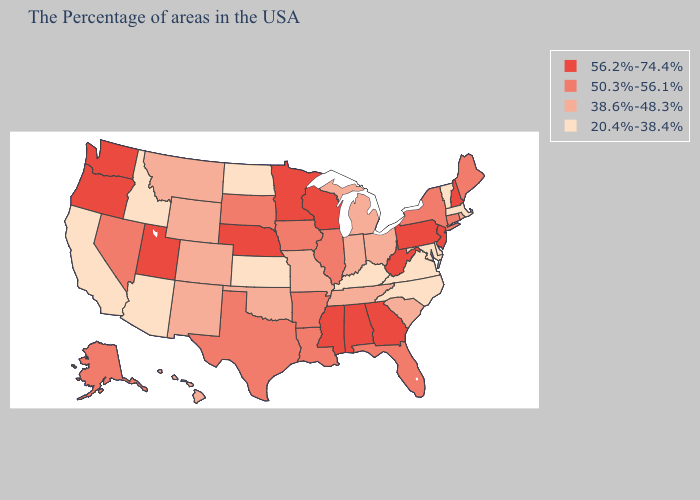Name the states that have a value in the range 56.2%-74.4%?
Quick response, please. New Hampshire, New Jersey, Pennsylvania, West Virginia, Georgia, Alabama, Wisconsin, Mississippi, Minnesota, Nebraska, Utah, Washington, Oregon. Does Georgia have the highest value in the South?
Answer briefly. Yes. What is the highest value in the USA?
Quick response, please. 56.2%-74.4%. Name the states that have a value in the range 50.3%-56.1%?
Answer briefly. Maine, Connecticut, New York, Florida, Illinois, Louisiana, Arkansas, Iowa, Texas, South Dakota, Nevada, Alaska. What is the highest value in states that border Connecticut?
Quick response, please. 50.3%-56.1%. Name the states that have a value in the range 56.2%-74.4%?
Give a very brief answer. New Hampshire, New Jersey, Pennsylvania, West Virginia, Georgia, Alabama, Wisconsin, Mississippi, Minnesota, Nebraska, Utah, Washington, Oregon. Among the states that border Montana , does South Dakota have the highest value?
Concise answer only. Yes. Among the states that border North Dakota , which have the lowest value?
Concise answer only. Montana. What is the value of West Virginia?
Give a very brief answer. 56.2%-74.4%. What is the value of Minnesota?
Concise answer only. 56.2%-74.4%. Does the map have missing data?
Short answer required. No. Does North Carolina have a higher value than Minnesota?
Write a very short answer. No. Does Pennsylvania have the highest value in the USA?
Concise answer only. Yes. Name the states that have a value in the range 20.4%-38.4%?
Write a very short answer. Massachusetts, Vermont, Delaware, Maryland, Virginia, North Carolina, Kentucky, Kansas, North Dakota, Arizona, Idaho, California. What is the value of North Dakota?
Answer briefly. 20.4%-38.4%. 